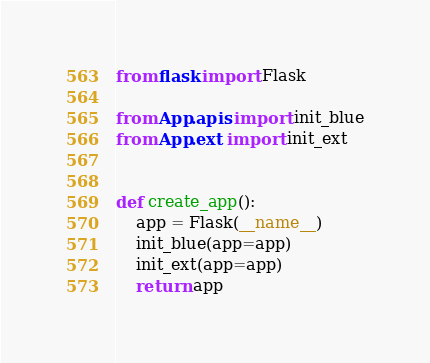Convert code to text. <code><loc_0><loc_0><loc_500><loc_500><_Python_>from flask import Flask

from App.apis import init_blue
from App.ext import init_ext


def create_app():
    app = Flask(__name__)
    init_blue(app=app)
    init_ext(app=app)
    return app</code> 